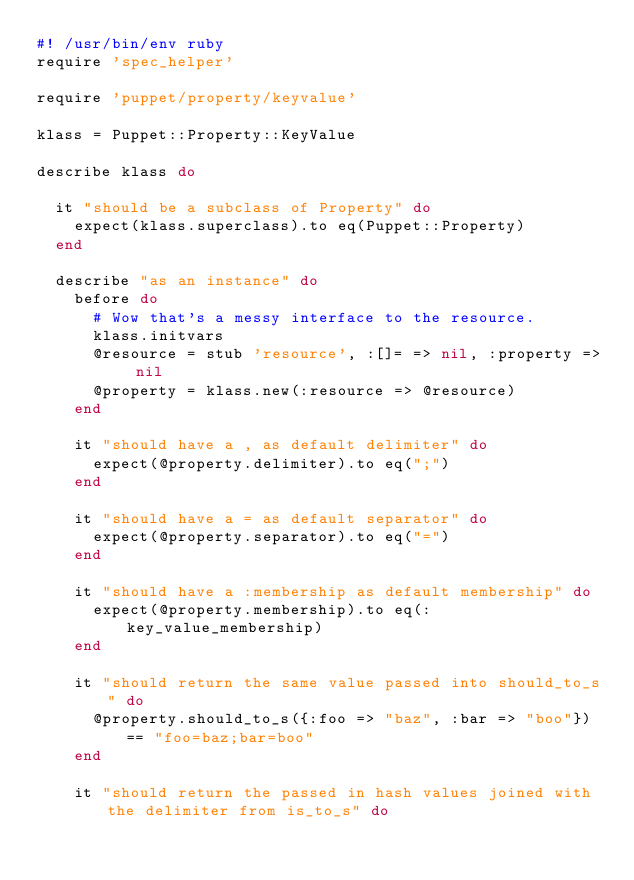<code> <loc_0><loc_0><loc_500><loc_500><_Ruby_>#! /usr/bin/env ruby
require 'spec_helper'

require 'puppet/property/keyvalue'

klass = Puppet::Property::KeyValue

describe klass do

  it "should be a subclass of Property" do
    expect(klass.superclass).to eq(Puppet::Property)
  end

  describe "as an instance" do
    before do
      # Wow that's a messy interface to the resource.
      klass.initvars
      @resource = stub 'resource', :[]= => nil, :property => nil
      @property = klass.new(:resource => @resource)
    end

    it "should have a , as default delimiter" do
      expect(@property.delimiter).to eq(";")
    end

    it "should have a = as default separator" do
      expect(@property.separator).to eq("=")
    end

    it "should have a :membership as default membership" do
      expect(@property.membership).to eq(:key_value_membership)
    end

    it "should return the same value passed into should_to_s" do
      @property.should_to_s({:foo => "baz", :bar => "boo"}) == "foo=baz;bar=boo"
    end

    it "should return the passed in hash values joined with the delimiter from is_to_s" do</code> 